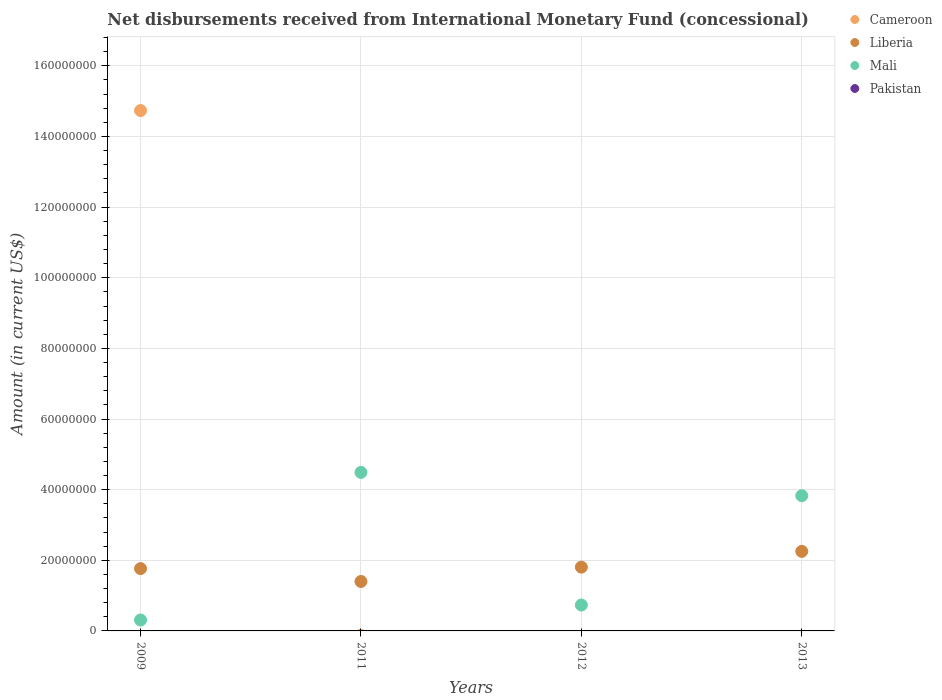Is the number of dotlines equal to the number of legend labels?
Your response must be concise. No. Across all years, what is the maximum amount of disbursements received from International Monetary Fund in Liberia?
Your answer should be very brief. 2.25e+07. Across all years, what is the minimum amount of disbursements received from International Monetary Fund in Liberia?
Offer a very short reply. 1.40e+07. In which year was the amount of disbursements received from International Monetary Fund in Mali maximum?
Your answer should be compact. 2011. What is the total amount of disbursements received from International Monetary Fund in Cameroon in the graph?
Ensure brevity in your answer.  1.47e+08. What is the difference between the amount of disbursements received from International Monetary Fund in Mali in 2011 and that in 2013?
Give a very brief answer. 6.60e+06. What is the difference between the amount of disbursements received from International Monetary Fund in Pakistan in 2013 and the amount of disbursements received from International Monetary Fund in Mali in 2009?
Make the answer very short. -3.08e+06. What is the average amount of disbursements received from International Monetary Fund in Mali per year?
Give a very brief answer. 2.34e+07. In the year 2009, what is the difference between the amount of disbursements received from International Monetary Fund in Liberia and amount of disbursements received from International Monetary Fund in Cameroon?
Ensure brevity in your answer.  -1.30e+08. What is the ratio of the amount of disbursements received from International Monetary Fund in Mali in 2009 to that in 2011?
Ensure brevity in your answer.  0.07. What is the difference between the highest and the second highest amount of disbursements received from International Monetary Fund in Mali?
Your answer should be very brief. 6.60e+06. What is the difference between the highest and the lowest amount of disbursements received from International Monetary Fund in Cameroon?
Your answer should be compact. 1.47e+08. In how many years, is the amount of disbursements received from International Monetary Fund in Pakistan greater than the average amount of disbursements received from International Monetary Fund in Pakistan taken over all years?
Your answer should be compact. 0. Is the sum of the amount of disbursements received from International Monetary Fund in Liberia in 2012 and 2013 greater than the maximum amount of disbursements received from International Monetary Fund in Pakistan across all years?
Provide a succinct answer. Yes. Is the amount of disbursements received from International Monetary Fund in Mali strictly greater than the amount of disbursements received from International Monetary Fund in Pakistan over the years?
Provide a succinct answer. Yes. Are the values on the major ticks of Y-axis written in scientific E-notation?
Give a very brief answer. No. Where does the legend appear in the graph?
Make the answer very short. Top right. What is the title of the graph?
Make the answer very short. Net disbursements received from International Monetary Fund (concessional). What is the label or title of the X-axis?
Ensure brevity in your answer.  Years. What is the label or title of the Y-axis?
Give a very brief answer. Amount (in current US$). What is the Amount (in current US$) of Cameroon in 2009?
Your answer should be compact. 1.47e+08. What is the Amount (in current US$) in Liberia in 2009?
Your response must be concise. 1.76e+07. What is the Amount (in current US$) of Mali in 2009?
Keep it short and to the point. 3.08e+06. What is the Amount (in current US$) in Liberia in 2011?
Provide a succinct answer. 1.40e+07. What is the Amount (in current US$) in Mali in 2011?
Your response must be concise. 4.49e+07. What is the Amount (in current US$) of Pakistan in 2011?
Your answer should be very brief. 0. What is the Amount (in current US$) in Cameroon in 2012?
Provide a short and direct response. 0. What is the Amount (in current US$) in Liberia in 2012?
Ensure brevity in your answer.  1.81e+07. What is the Amount (in current US$) of Mali in 2012?
Offer a very short reply. 7.33e+06. What is the Amount (in current US$) of Liberia in 2013?
Provide a succinct answer. 2.25e+07. What is the Amount (in current US$) of Mali in 2013?
Your answer should be very brief. 3.83e+07. Across all years, what is the maximum Amount (in current US$) of Cameroon?
Ensure brevity in your answer.  1.47e+08. Across all years, what is the maximum Amount (in current US$) in Liberia?
Make the answer very short. 2.25e+07. Across all years, what is the maximum Amount (in current US$) in Mali?
Your response must be concise. 4.49e+07. Across all years, what is the minimum Amount (in current US$) in Cameroon?
Keep it short and to the point. 0. Across all years, what is the minimum Amount (in current US$) of Liberia?
Keep it short and to the point. 1.40e+07. Across all years, what is the minimum Amount (in current US$) in Mali?
Provide a short and direct response. 3.08e+06. What is the total Amount (in current US$) in Cameroon in the graph?
Provide a short and direct response. 1.47e+08. What is the total Amount (in current US$) of Liberia in the graph?
Your answer should be very brief. 7.22e+07. What is the total Amount (in current US$) of Mali in the graph?
Your answer should be compact. 9.36e+07. What is the total Amount (in current US$) in Pakistan in the graph?
Give a very brief answer. 0. What is the difference between the Amount (in current US$) of Liberia in 2009 and that in 2011?
Provide a short and direct response. 3.64e+06. What is the difference between the Amount (in current US$) of Mali in 2009 and that in 2011?
Offer a very short reply. -4.18e+07. What is the difference between the Amount (in current US$) in Liberia in 2009 and that in 2012?
Offer a very short reply. -4.13e+05. What is the difference between the Amount (in current US$) in Mali in 2009 and that in 2012?
Make the answer very short. -4.25e+06. What is the difference between the Amount (in current US$) in Liberia in 2009 and that in 2013?
Provide a short and direct response. -4.88e+06. What is the difference between the Amount (in current US$) in Mali in 2009 and that in 2013?
Your response must be concise. -3.52e+07. What is the difference between the Amount (in current US$) of Liberia in 2011 and that in 2012?
Offer a terse response. -4.06e+06. What is the difference between the Amount (in current US$) in Mali in 2011 and that in 2012?
Your answer should be compact. 3.76e+07. What is the difference between the Amount (in current US$) of Liberia in 2011 and that in 2013?
Ensure brevity in your answer.  -8.52e+06. What is the difference between the Amount (in current US$) in Mali in 2011 and that in 2013?
Offer a terse response. 6.60e+06. What is the difference between the Amount (in current US$) in Liberia in 2012 and that in 2013?
Your response must be concise. -4.46e+06. What is the difference between the Amount (in current US$) of Mali in 2012 and that in 2013?
Offer a terse response. -3.10e+07. What is the difference between the Amount (in current US$) in Cameroon in 2009 and the Amount (in current US$) in Liberia in 2011?
Provide a succinct answer. 1.33e+08. What is the difference between the Amount (in current US$) in Cameroon in 2009 and the Amount (in current US$) in Mali in 2011?
Ensure brevity in your answer.  1.02e+08. What is the difference between the Amount (in current US$) of Liberia in 2009 and the Amount (in current US$) of Mali in 2011?
Provide a short and direct response. -2.72e+07. What is the difference between the Amount (in current US$) in Cameroon in 2009 and the Amount (in current US$) in Liberia in 2012?
Offer a very short reply. 1.29e+08. What is the difference between the Amount (in current US$) of Cameroon in 2009 and the Amount (in current US$) of Mali in 2012?
Your response must be concise. 1.40e+08. What is the difference between the Amount (in current US$) in Liberia in 2009 and the Amount (in current US$) in Mali in 2012?
Provide a short and direct response. 1.03e+07. What is the difference between the Amount (in current US$) in Cameroon in 2009 and the Amount (in current US$) in Liberia in 2013?
Your answer should be very brief. 1.25e+08. What is the difference between the Amount (in current US$) of Cameroon in 2009 and the Amount (in current US$) of Mali in 2013?
Keep it short and to the point. 1.09e+08. What is the difference between the Amount (in current US$) of Liberia in 2009 and the Amount (in current US$) of Mali in 2013?
Offer a terse response. -2.06e+07. What is the difference between the Amount (in current US$) in Liberia in 2011 and the Amount (in current US$) in Mali in 2012?
Keep it short and to the point. 6.67e+06. What is the difference between the Amount (in current US$) of Liberia in 2011 and the Amount (in current US$) of Mali in 2013?
Your answer should be very brief. -2.43e+07. What is the difference between the Amount (in current US$) in Liberia in 2012 and the Amount (in current US$) in Mali in 2013?
Offer a very short reply. -2.02e+07. What is the average Amount (in current US$) in Cameroon per year?
Your answer should be very brief. 3.68e+07. What is the average Amount (in current US$) of Liberia per year?
Your answer should be very brief. 1.81e+07. What is the average Amount (in current US$) of Mali per year?
Give a very brief answer. 2.34e+07. What is the average Amount (in current US$) of Pakistan per year?
Ensure brevity in your answer.  0. In the year 2009, what is the difference between the Amount (in current US$) of Cameroon and Amount (in current US$) of Liberia?
Make the answer very short. 1.30e+08. In the year 2009, what is the difference between the Amount (in current US$) of Cameroon and Amount (in current US$) of Mali?
Your response must be concise. 1.44e+08. In the year 2009, what is the difference between the Amount (in current US$) in Liberia and Amount (in current US$) in Mali?
Provide a succinct answer. 1.46e+07. In the year 2011, what is the difference between the Amount (in current US$) of Liberia and Amount (in current US$) of Mali?
Your answer should be compact. -3.09e+07. In the year 2012, what is the difference between the Amount (in current US$) of Liberia and Amount (in current US$) of Mali?
Give a very brief answer. 1.07e+07. In the year 2013, what is the difference between the Amount (in current US$) of Liberia and Amount (in current US$) of Mali?
Give a very brief answer. -1.58e+07. What is the ratio of the Amount (in current US$) of Liberia in 2009 to that in 2011?
Make the answer very short. 1.26. What is the ratio of the Amount (in current US$) in Mali in 2009 to that in 2011?
Your response must be concise. 0.07. What is the ratio of the Amount (in current US$) of Liberia in 2009 to that in 2012?
Provide a succinct answer. 0.98. What is the ratio of the Amount (in current US$) in Mali in 2009 to that in 2012?
Give a very brief answer. 0.42. What is the ratio of the Amount (in current US$) in Liberia in 2009 to that in 2013?
Your answer should be compact. 0.78. What is the ratio of the Amount (in current US$) of Mali in 2009 to that in 2013?
Your answer should be compact. 0.08. What is the ratio of the Amount (in current US$) in Liberia in 2011 to that in 2012?
Give a very brief answer. 0.78. What is the ratio of the Amount (in current US$) of Mali in 2011 to that in 2012?
Keep it short and to the point. 6.12. What is the ratio of the Amount (in current US$) of Liberia in 2011 to that in 2013?
Give a very brief answer. 0.62. What is the ratio of the Amount (in current US$) of Mali in 2011 to that in 2013?
Your response must be concise. 1.17. What is the ratio of the Amount (in current US$) of Liberia in 2012 to that in 2013?
Make the answer very short. 0.8. What is the ratio of the Amount (in current US$) in Mali in 2012 to that in 2013?
Ensure brevity in your answer.  0.19. What is the difference between the highest and the second highest Amount (in current US$) in Liberia?
Make the answer very short. 4.46e+06. What is the difference between the highest and the second highest Amount (in current US$) of Mali?
Provide a short and direct response. 6.60e+06. What is the difference between the highest and the lowest Amount (in current US$) of Cameroon?
Your response must be concise. 1.47e+08. What is the difference between the highest and the lowest Amount (in current US$) in Liberia?
Your answer should be compact. 8.52e+06. What is the difference between the highest and the lowest Amount (in current US$) in Mali?
Keep it short and to the point. 4.18e+07. 